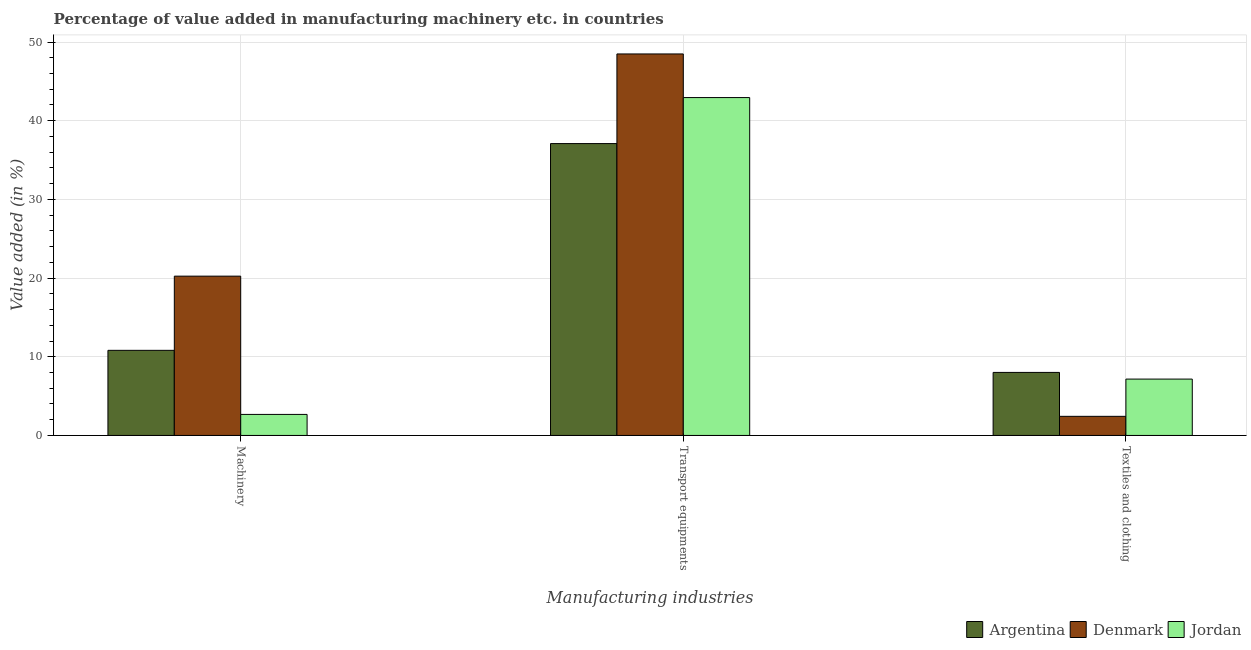Are the number of bars on each tick of the X-axis equal?
Your response must be concise. Yes. What is the label of the 1st group of bars from the left?
Your answer should be compact. Machinery. What is the value added in manufacturing transport equipments in Denmark?
Offer a very short reply. 48.48. Across all countries, what is the maximum value added in manufacturing machinery?
Keep it short and to the point. 20.25. Across all countries, what is the minimum value added in manufacturing textile and clothing?
Offer a terse response. 2.43. In which country was the value added in manufacturing transport equipments minimum?
Offer a very short reply. Argentina. What is the total value added in manufacturing machinery in the graph?
Offer a very short reply. 33.73. What is the difference between the value added in manufacturing transport equipments in Argentina and that in Denmark?
Your answer should be compact. -11.39. What is the difference between the value added in manufacturing textile and clothing in Denmark and the value added in manufacturing machinery in Jordan?
Make the answer very short. -0.24. What is the average value added in manufacturing transport equipments per country?
Provide a short and direct response. 42.84. What is the difference between the value added in manufacturing textile and clothing and value added in manufacturing transport equipments in Denmark?
Your answer should be compact. -46.06. In how many countries, is the value added in manufacturing textile and clothing greater than 28 %?
Your response must be concise. 0. What is the ratio of the value added in manufacturing machinery in Argentina to that in Jordan?
Provide a short and direct response. 4.05. What is the difference between the highest and the second highest value added in manufacturing textile and clothing?
Your answer should be very brief. 0.85. What is the difference between the highest and the lowest value added in manufacturing transport equipments?
Offer a terse response. 11.39. What does the 3rd bar from the left in Textiles and clothing represents?
Your answer should be very brief. Jordan. What does the 1st bar from the right in Textiles and clothing represents?
Ensure brevity in your answer.  Jordan. Are the values on the major ticks of Y-axis written in scientific E-notation?
Give a very brief answer. No. Does the graph contain grids?
Make the answer very short. Yes. How many legend labels are there?
Offer a terse response. 3. What is the title of the graph?
Your response must be concise. Percentage of value added in manufacturing machinery etc. in countries. Does "Bhutan" appear as one of the legend labels in the graph?
Ensure brevity in your answer.  No. What is the label or title of the X-axis?
Keep it short and to the point. Manufacturing industries. What is the label or title of the Y-axis?
Provide a succinct answer. Value added (in %). What is the Value added (in %) in Argentina in Machinery?
Your response must be concise. 10.82. What is the Value added (in %) of Denmark in Machinery?
Ensure brevity in your answer.  20.25. What is the Value added (in %) in Jordan in Machinery?
Make the answer very short. 2.67. What is the Value added (in %) in Argentina in Transport equipments?
Offer a terse response. 37.09. What is the Value added (in %) of Denmark in Transport equipments?
Offer a terse response. 48.48. What is the Value added (in %) of Jordan in Transport equipments?
Provide a succinct answer. 42.94. What is the Value added (in %) in Argentina in Textiles and clothing?
Keep it short and to the point. 8.01. What is the Value added (in %) of Denmark in Textiles and clothing?
Your answer should be very brief. 2.43. What is the Value added (in %) of Jordan in Textiles and clothing?
Your response must be concise. 7.16. Across all Manufacturing industries, what is the maximum Value added (in %) in Argentina?
Your answer should be compact. 37.09. Across all Manufacturing industries, what is the maximum Value added (in %) of Denmark?
Your response must be concise. 48.48. Across all Manufacturing industries, what is the maximum Value added (in %) of Jordan?
Provide a succinct answer. 42.94. Across all Manufacturing industries, what is the minimum Value added (in %) of Argentina?
Offer a very short reply. 8.01. Across all Manufacturing industries, what is the minimum Value added (in %) in Denmark?
Provide a succinct answer. 2.43. Across all Manufacturing industries, what is the minimum Value added (in %) in Jordan?
Offer a very short reply. 2.67. What is the total Value added (in %) in Argentina in the graph?
Provide a succinct answer. 55.92. What is the total Value added (in %) in Denmark in the graph?
Your response must be concise. 71.16. What is the total Value added (in %) of Jordan in the graph?
Provide a short and direct response. 52.77. What is the difference between the Value added (in %) of Argentina in Machinery and that in Transport equipments?
Keep it short and to the point. -26.28. What is the difference between the Value added (in %) of Denmark in Machinery and that in Transport equipments?
Provide a short and direct response. -28.24. What is the difference between the Value added (in %) in Jordan in Machinery and that in Transport equipments?
Your answer should be compact. -40.27. What is the difference between the Value added (in %) of Argentina in Machinery and that in Textiles and clothing?
Make the answer very short. 2.81. What is the difference between the Value added (in %) in Denmark in Machinery and that in Textiles and clothing?
Give a very brief answer. 17.82. What is the difference between the Value added (in %) in Jordan in Machinery and that in Textiles and clothing?
Your answer should be very brief. -4.49. What is the difference between the Value added (in %) in Argentina in Transport equipments and that in Textiles and clothing?
Provide a short and direct response. 29.08. What is the difference between the Value added (in %) in Denmark in Transport equipments and that in Textiles and clothing?
Provide a succinct answer. 46.06. What is the difference between the Value added (in %) in Jordan in Transport equipments and that in Textiles and clothing?
Ensure brevity in your answer.  35.78. What is the difference between the Value added (in %) in Argentina in Machinery and the Value added (in %) in Denmark in Transport equipments?
Keep it short and to the point. -37.67. What is the difference between the Value added (in %) in Argentina in Machinery and the Value added (in %) in Jordan in Transport equipments?
Your response must be concise. -32.12. What is the difference between the Value added (in %) in Denmark in Machinery and the Value added (in %) in Jordan in Transport equipments?
Ensure brevity in your answer.  -22.7. What is the difference between the Value added (in %) in Argentina in Machinery and the Value added (in %) in Denmark in Textiles and clothing?
Your answer should be compact. 8.39. What is the difference between the Value added (in %) in Argentina in Machinery and the Value added (in %) in Jordan in Textiles and clothing?
Provide a short and direct response. 3.66. What is the difference between the Value added (in %) of Denmark in Machinery and the Value added (in %) of Jordan in Textiles and clothing?
Keep it short and to the point. 13.08. What is the difference between the Value added (in %) of Argentina in Transport equipments and the Value added (in %) of Denmark in Textiles and clothing?
Your response must be concise. 34.66. What is the difference between the Value added (in %) of Argentina in Transport equipments and the Value added (in %) of Jordan in Textiles and clothing?
Give a very brief answer. 29.93. What is the difference between the Value added (in %) in Denmark in Transport equipments and the Value added (in %) in Jordan in Textiles and clothing?
Your response must be concise. 41.32. What is the average Value added (in %) of Argentina per Manufacturing industries?
Give a very brief answer. 18.64. What is the average Value added (in %) of Denmark per Manufacturing industries?
Offer a very short reply. 23.72. What is the average Value added (in %) of Jordan per Manufacturing industries?
Provide a succinct answer. 17.59. What is the difference between the Value added (in %) of Argentina and Value added (in %) of Denmark in Machinery?
Your answer should be very brief. -9.43. What is the difference between the Value added (in %) in Argentina and Value added (in %) in Jordan in Machinery?
Your response must be concise. 8.15. What is the difference between the Value added (in %) of Denmark and Value added (in %) of Jordan in Machinery?
Provide a short and direct response. 17.57. What is the difference between the Value added (in %) of Argentina and Value added (in %) of Denmark in Transport equipments?
Offer a terse response. -11.39. What is the difference between the Value added (in %) in Argentina and Value added (in %) in Jordan in Transport equipments?
Make the answer very short. -5.85. What is the difference between the Value added (in %) of Denmark and Value added (in %) of Jordan in Transport equipments?
Make the answer very short. 5.54. What is the difference between the Value added (in %) in Argentina and Value added (in %) in Denmark in Textiles and clothing?
Your answer should be compact. 5.58. What is the difference between the Value added (in %) in Argentina and Value added (in %) in Jordan in Textiles and clothing?
Keep it short and to the point. 0.85. What is the difference between the Value added (in %) in Denmark and Value added (in %) in Jordan in Textiles and clothing?
Make the answer very short. -4.73. What is the ratio of the Value added (in %) of Argentina in Machinery to that in Transport equipments?
Ensure brevity in your answer.  0.29. What is the ratio of the Value added (in %) in Denmark in Machinery to that in Transport equipments?
Your answer should be compact. 0.42. What is the ratio of the Value added (in %) in Jordan in Machinery to that in Transport equipments?
Your answer should be very brief. 0.06. What is the ratio of the Value added (in %) of Argentina in Machinery to that in Textiles and clothing?
Your answer should be compact. 1.35. What is the ratio of the Value added (in %) in Denmark in Machinery to that in Textiles and clothing?
Offer a very short reply. 8.34. What is the ratio of the Value added (in %) of Jordan in Machinery to that in Textiles and clothing?
Your response must be concise. 0.37. What is the ratio of the Value added (in %) of Argentina in Transport equipments to that in Textiles and clothing?
Your response must be concise. 4.63. What is the ratio of the Value added (in %) of Denmark in Transport equipments to that in Textiles and clothing?
Provide a short and direct response. 19.97. What is the ratio of the Value added (in %) of Jordan in Transport equipments to that in Textiles and clothing?
Make the answer very short. 6. What is the difference between the highest and the second highest Value added (in %) in Argentina?
Ensure brevity in your answer.  26.28. What is the difference between the highest and the second highest Value added (in %) in Denmark?
Your answer should be very brief. 28.24. What is the difference between the highest and the second highest Value added (in %) in Jordan?
Give a very brief answer. 35.78. What is the difference between the highest and the lowest Value added (in %) in Argentina?
Give a very brief answer. 29.08. What is the difference between the highest and the lowest Value added (in %) in Denmark?
Make the answer very short. 46.06. What is the difference between the highest and the lowest Value added (in %) in Jordan?
Ensure brevity in your answer.  40.27. 